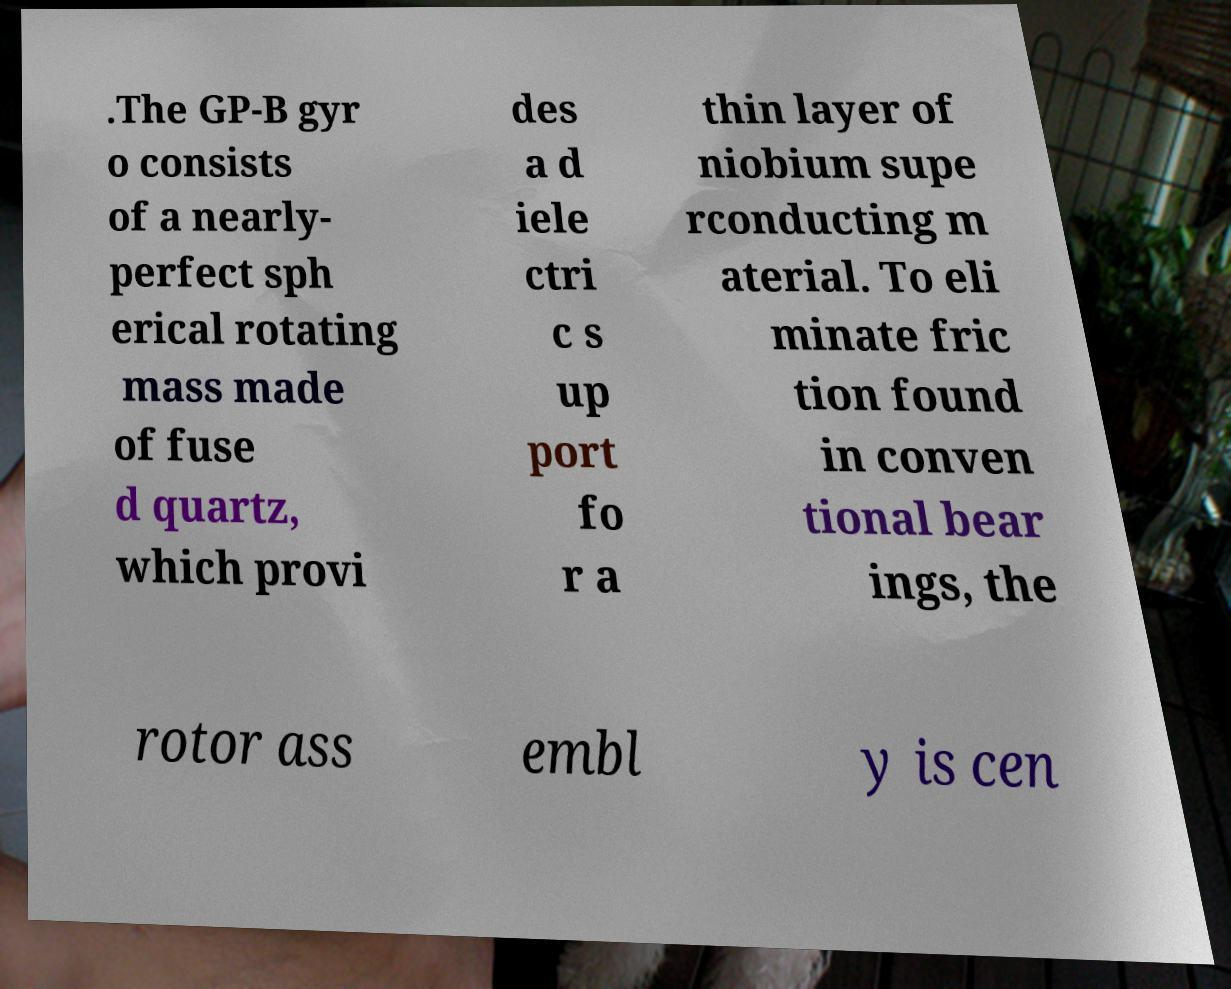There's text embedded in this image that I need extracted. Can you transcribe it verbatim? .The GP-B gyr o consists of a nearly- perfect sph erical rotating mass made of fuse d quartz, which provi des a d iele ctri c s up port fo r a thin layer of niobium supe rconducting m aterial. To eli minate fric tion found in conven tional bear ings, the rotor ass embl y is cen 